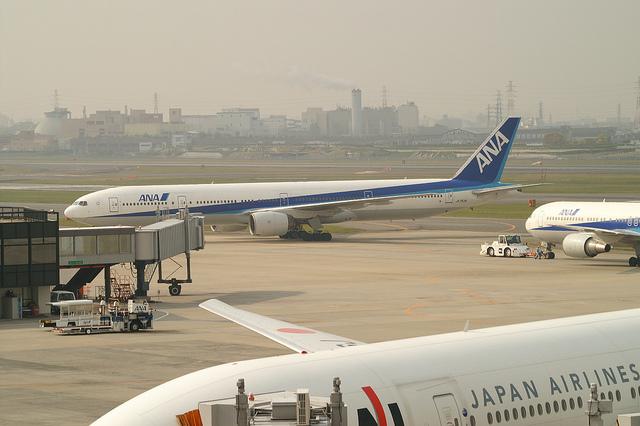What airline is the first plane?
Keep it brief. Japan airlines. Where are the planes?
Write a very short answer. Airport. Is there a Japanese plane on the ground?
Short answer required. Yes. What is the object with ana on it?
Give a very brief answer. Plane. 